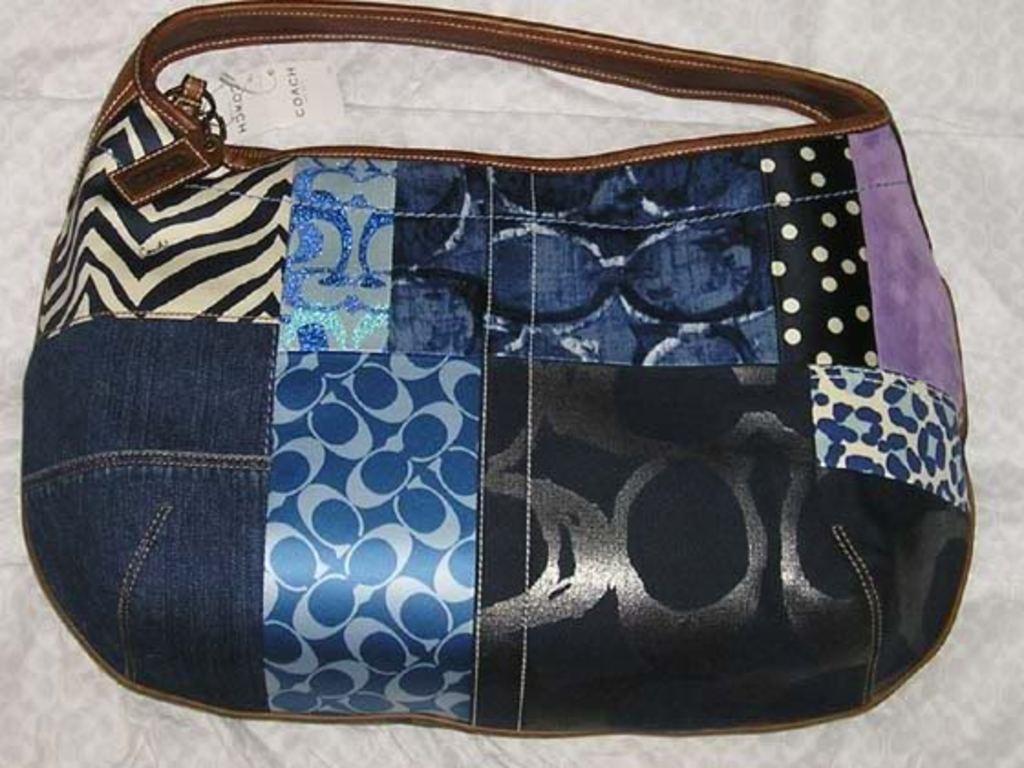Could you give a brief overview of what you see in this image? This picture describe about the blue color multi fabric patterns and denim ladies purse. On the top we can see the brown leather handle , On the left we can see the zebra pattern leather , On The left we can see cheetah pattern cloth and blue pattern design fabric. 